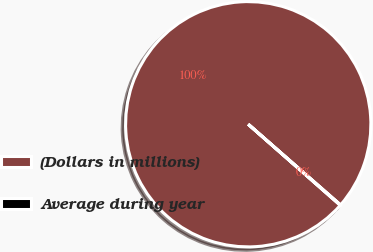Convert chart. <chart><loc_0><loc_0><loc_500><loc_500><pie_chart><fcel>(Dollars in millions)<fcel>Average during year<nl><fcel>99.94%<fcel>0.06%<nl></chart> 